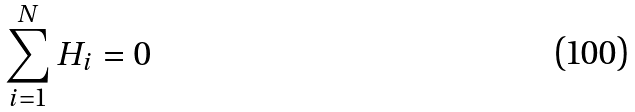<formula> <loc_0><loc_0><loc_500><loc_500>\sum _ { i = 1 } ^ { N } H _ { i } = 0</formula> 